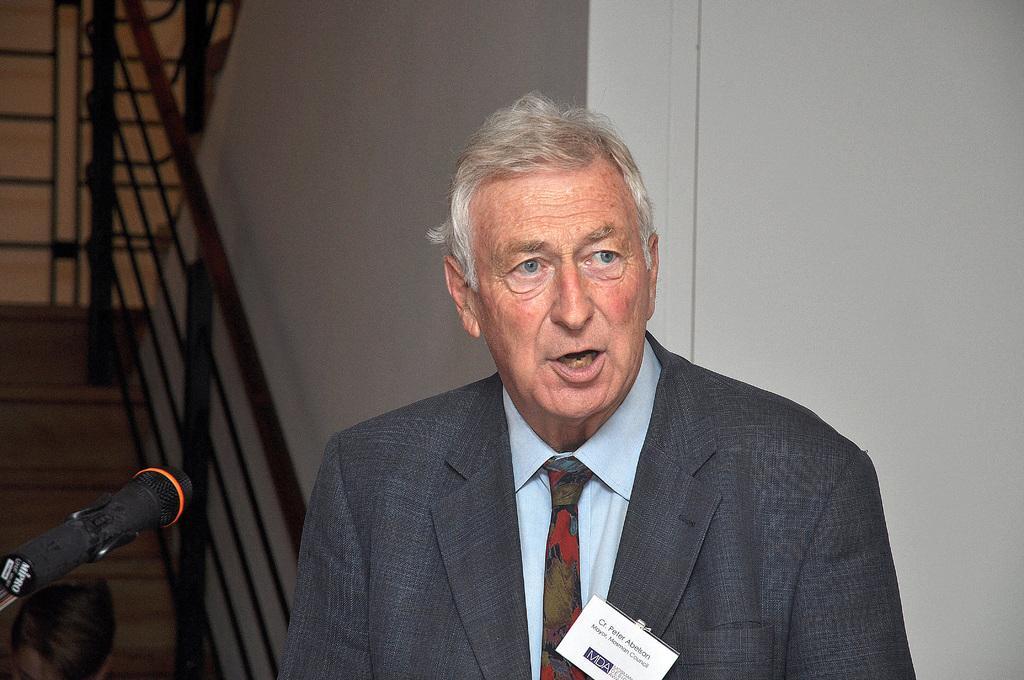Please provide a concise description of this image. In this picture there is an old man wearing black color coat is speaking something and looking to the right side. Beside there is a black color microphone. Behind there is a white color wall and some steps with black color fencing railing. 